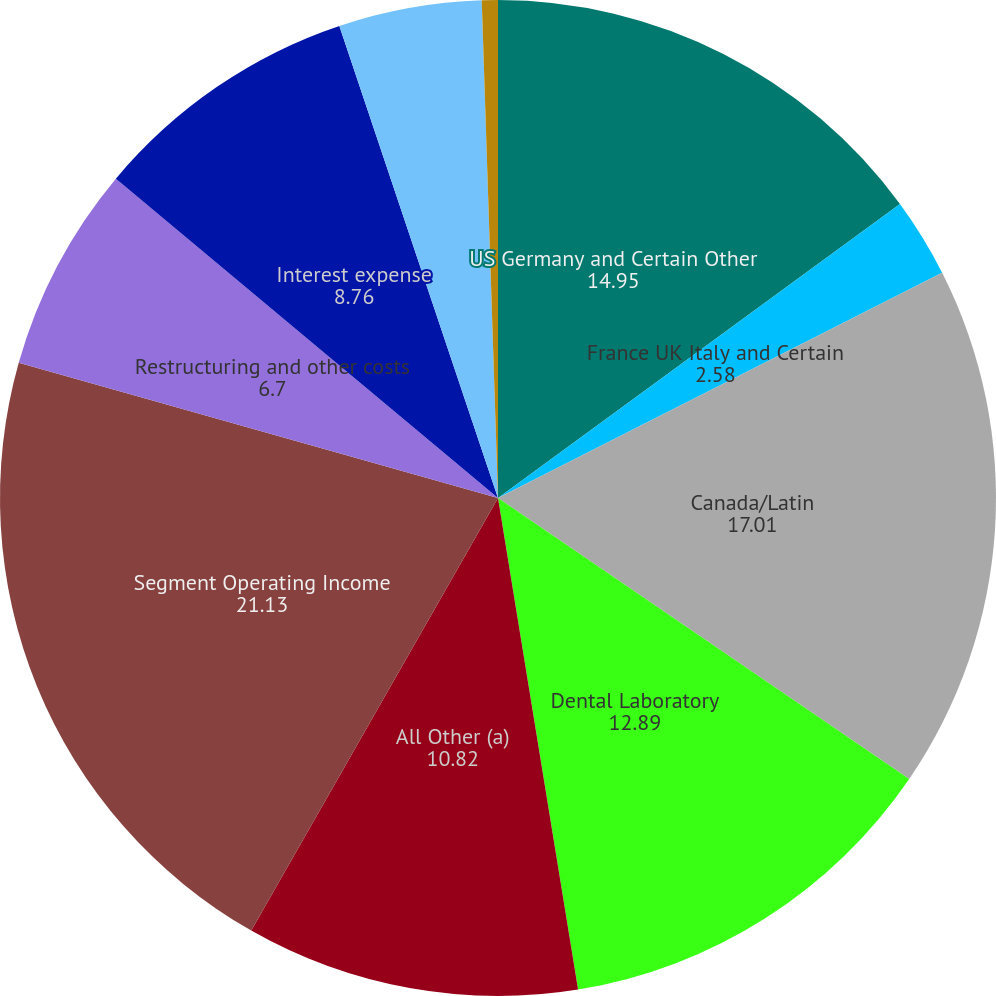<chart> <loc_0><loc_0><loc_500><loc_500><pie_chart><fcel>US Germany and Certain Other<fcel>France UK Italy and Certain<fcel>Canada/Latin<fcel>Dental Laboratory<fcel>All Other (a)<fcel>Segment Operating Income<fcel>Restructuring and other costs<fcel>Interest expense<fcel>Interest income<fcel>Other expense (income) net<nl><fcel>14.95%<fcel>2.58%<fcel>17.01%<fcel>12.89%<fcel>10.82%<fcel>21.13%<fcel>6.7%<fcel>8.76%<fcel>4.64%<fcel>0.52%<nl></chart> 